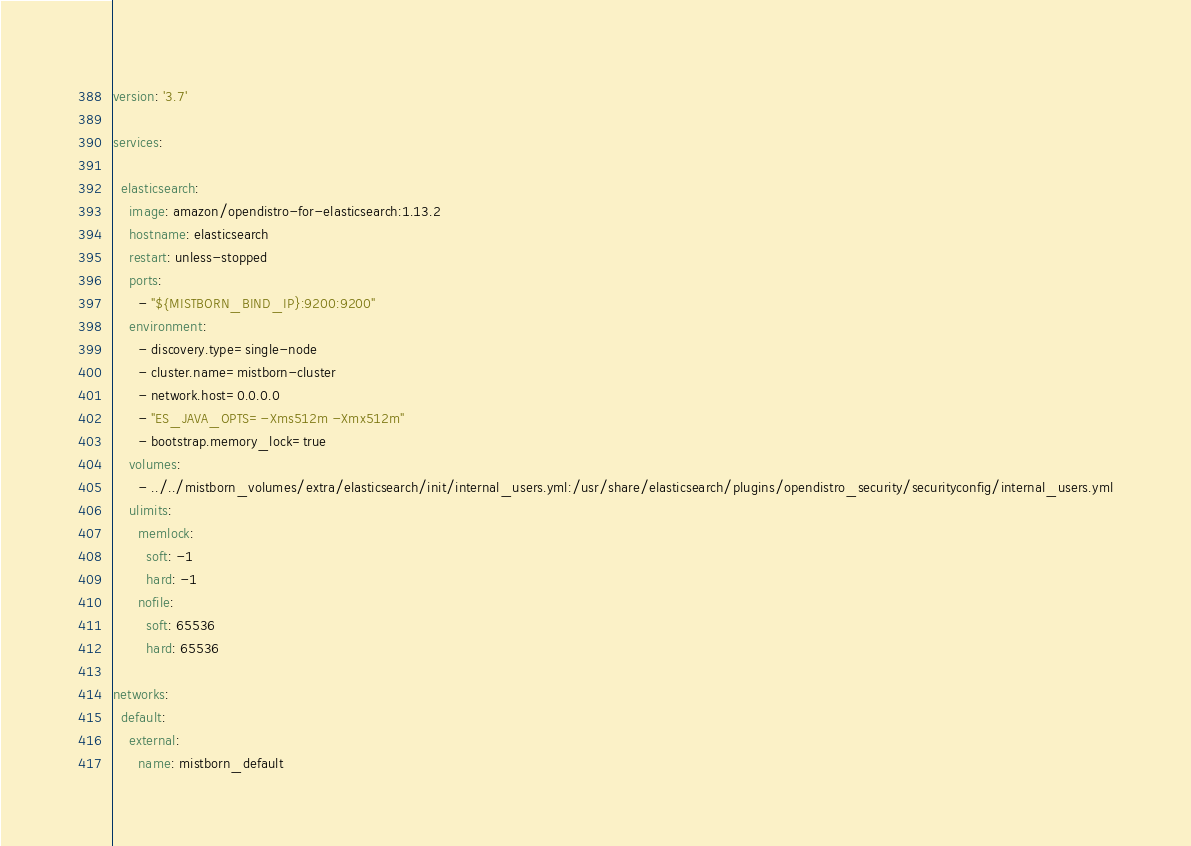Convert code to text. <code><loc_0><loc_0><loc_500><loc_500><_YAML_>version: '3.7'

services:

  elasticsearch:
    image: amazon/opendistro-for-elasticsearch:1.13.2
    hostname: elasticsearch
    restart: unless-stopped
    ports:
      - "${MISTBORN_BIND_IP}:9200:9200"
    environment:
      - discovery.type=single-node
      - cluster.name=mistborn-cluster
      - network.host=0.0.0.0
      - "ES_JAVA_OPTS=-Xms512m -Xmx512m"
      - bootstrap.memory_lock=true
    volumes:
      - ../../mistborn_volumes/extra/elasticsearch/init/internal_users.yml:/usr/share/elasticsearch/plugins/opendistro_security/securityconfig/internal_users.yml
    ulimits:
      memlock:
        soft: -1
        hard: -1
      nofile:
        soft: 65536
        hard: 65536

networks:
  default:
    external:
      name: mistborn_default
</code> 